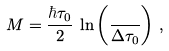Convert formula to latex. <formula><loc_0><loc_0><loc_500><loc_500>M = \frac { \hbar { \tau } _ { 0 } } { 2 } \, \ln \left ( \frac { } { \Delta \tau _ { 0 } } \right ) \, ,</formula> 